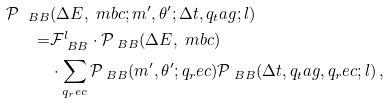<formula> <loc_0><loc_0><loc_500><loc_500>\mathcal { P } _ { \ B B } & ( \Delta E , \ m b c ; m ^ { \prime } , \theta ^ { \prime } ; \Delta t , q _ { t } a g ; l ) \\ = & \mathcal { F } ^ { l } _ { \ B B } \cdot \mathcal { P } _ { \ B B } ( \Delta E , \ m b c ) \\ & \cdot \sum _ { q _ { r } e c } \mathcal { P } _ { \ B B } ( m ^ { \prime } , \theta ^ { \prime } ; q _ { r } e c ) \mathcal { P } _ { \ B B } ( \Delta t , q _ { t } a g , q _ { r } e c ; l ) \, ,</formula> 